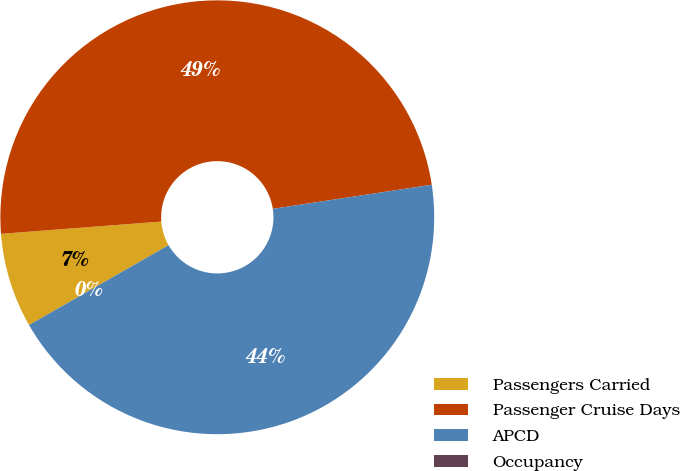Convert chart. <chart><loc_0><loc_0><loc_500><loc_500><pie_chart><fcel>Passengers Carried<fcel>Passenger Cruise Days<fcel>APCD<fcel>Occupancy<nl><fcel>7.06%<fcel>48.82%<fcel>44.12%<fcel>0.0%<nl></chart> 